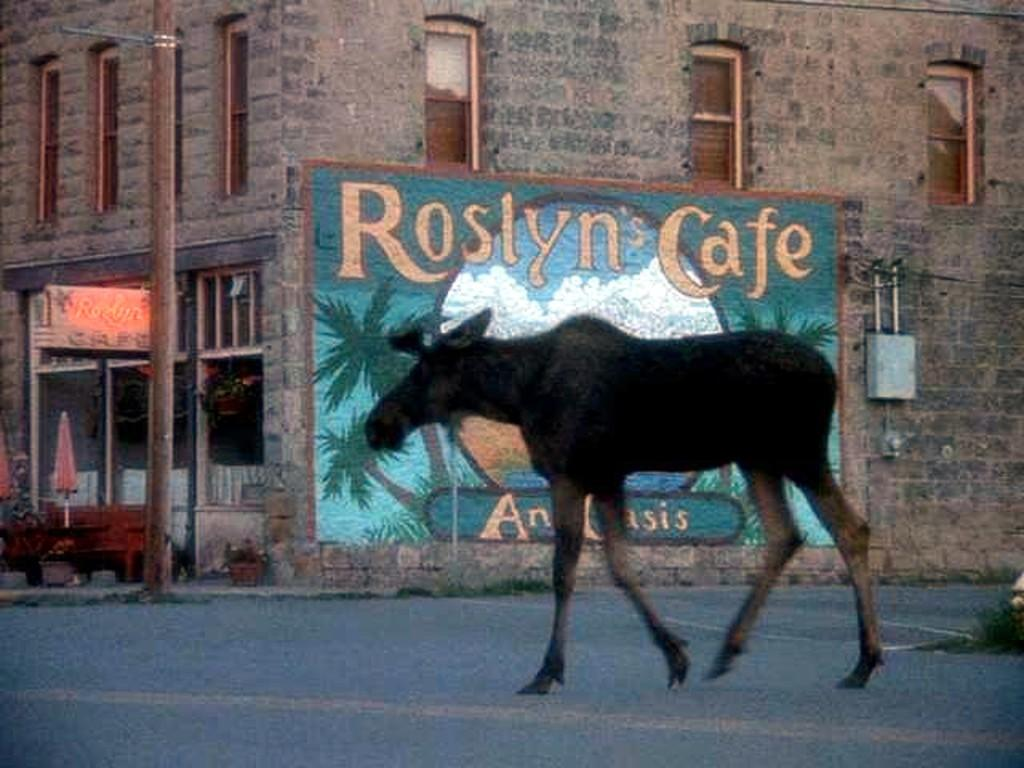What is on the road in the image? There is an animal on the road in the image. What can be seen on the wall in the image? There is a painting on the wall in the image. What is the tall, vertical object in the image? There is a pole in the image. What is the flat, rectangular object in the image? There is a board in the image. What is the small, container-like object in the image? There is a box in the image. What is the long, horizontal object with a backrest in the image? There is a bench in the image. What can be seen in the background of the image? There is a building and windows visible in the background of the image. Can you tell me how many lamps are on the bench in the image? There are no lamps present in the image; the objects mentioned are an animal, a painting, a pole, a board, a box, a bench, a building, and windows. Is there a doctor attending to the animal on the road in the image? There is no doctor present in the image; the only subject mentioned on the road is an animal. 